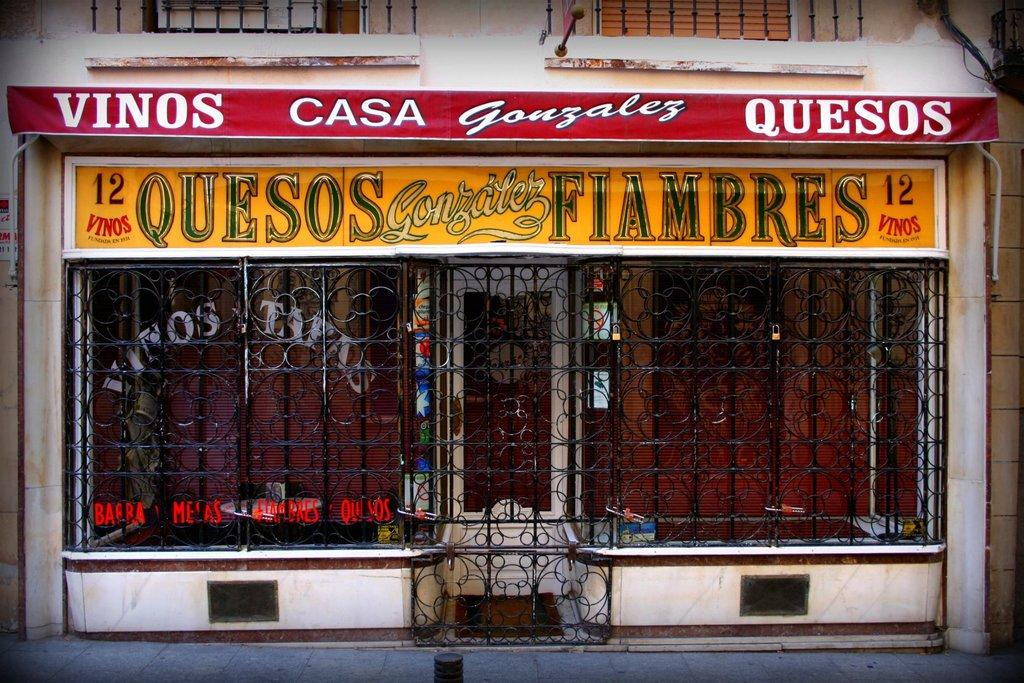What is the main object in the image? There is a grill in the image. What can be seen in the background of the image? There is a building and boards with text in the background of the image. How many oranges are floating in the ocean in the image? There are no oranges or ocean present in the image; it features a grill and a background with a building and boards with text. 